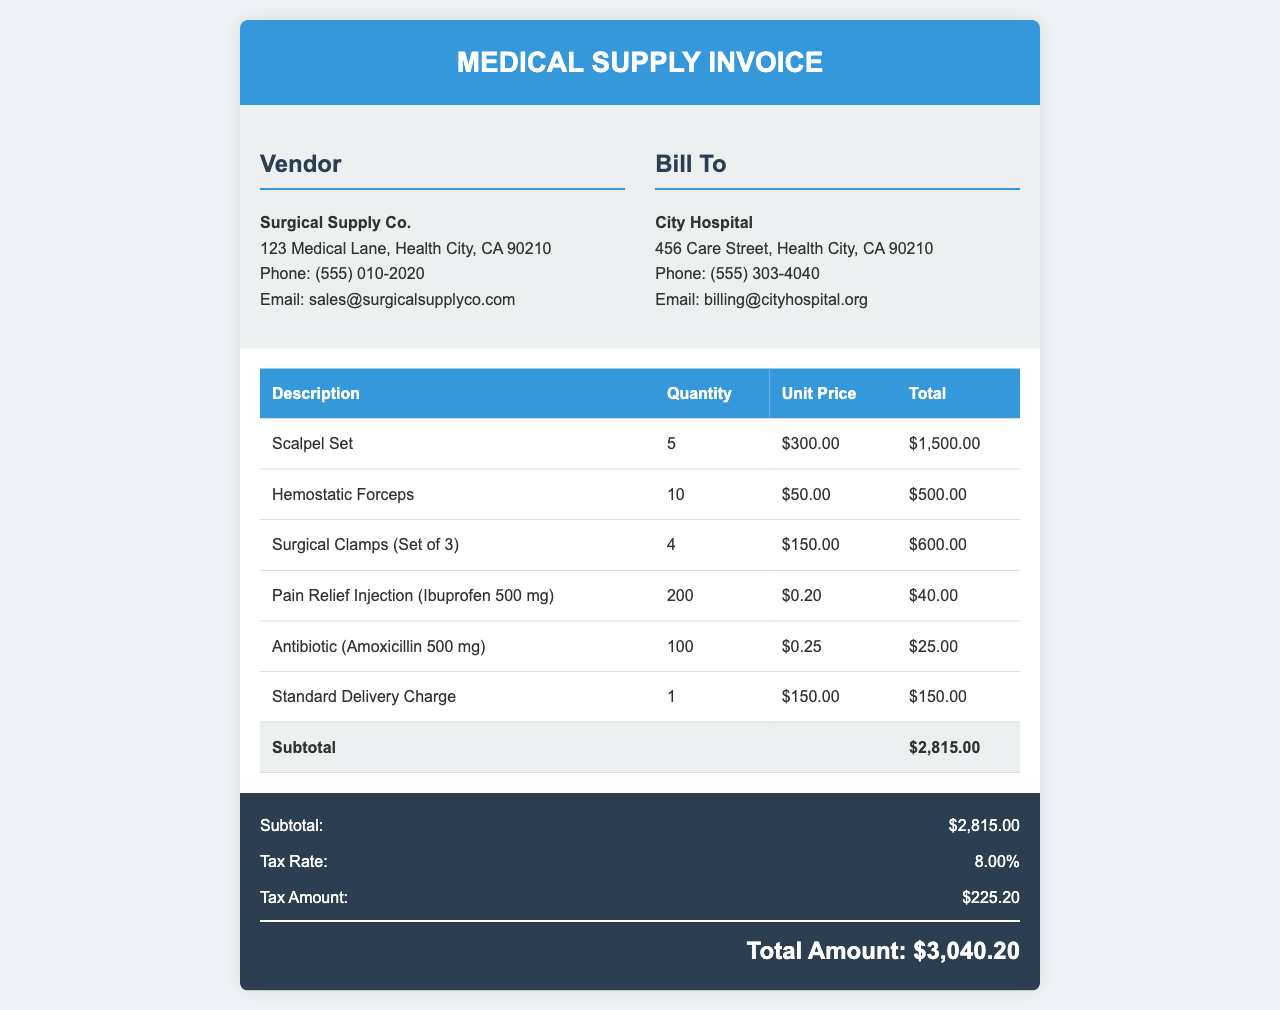What is the name of the vendor? The vendor is clearly listed at the top of the invoice as the supplier of the medical supplies.
Answer: Surgical Supply Co What is the total amount billed? The total amount billed is prominently displayed in the invoice summary section.
Answer: $3,040.20 How many scalpel sets were purchased? The quantity of scalpel sets is specified in the line item for that product.
Answer: 5 What is the tax rate applied to the invoice? The tax rate is mentioned in the summary section of the invoice.
Answer: 8.00% What is the delivery charge? The delivery charge is itemized in the invoice under the relevant heading.
Answer: $150.00 What is the subtotal before tax? The subtotal is detailed in the total row of the itemized list before calculating the tax.
Answer: $2,815.00 How many units of Ibuprofen were ordered? The document specifies the quantity ordered for the Pain Relief Injection line item.
Answer: 200 What is the address of the City Hospital? The billing details in the document provide the full address for the City Hospital.
Answer: 456 Care Street, Health City, CA 90210 What item has the lowest unit price? By evaluating the unit prices for each item, the one with the lowest price can be identified.
Answer: Pain Relief Injection (Ibuprofen 500 mg) 